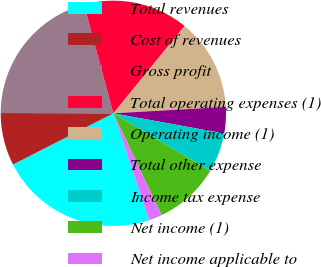Convert chart. <chart><loc_0><loc_0><loc_500><loc_500><pie_chart><fcel>Total revenues<fcel>Cost of revenues<fcel>Gross profit<fcel>Total operating expenses (1)<fcel>Operating income (1)<fcel>Total other expense<fcel>Income tax expense<fcel>Net income (1)<fcel>Net income applicable to<nl><fcel>22.64%<fcel>7.55%<fcel>20.75%<fcel>15.09%<fcel>13.21%<fcel>3.77%<fcel>5.66%<fcel>9.43%<fcel>1.89%<nl></chart> 